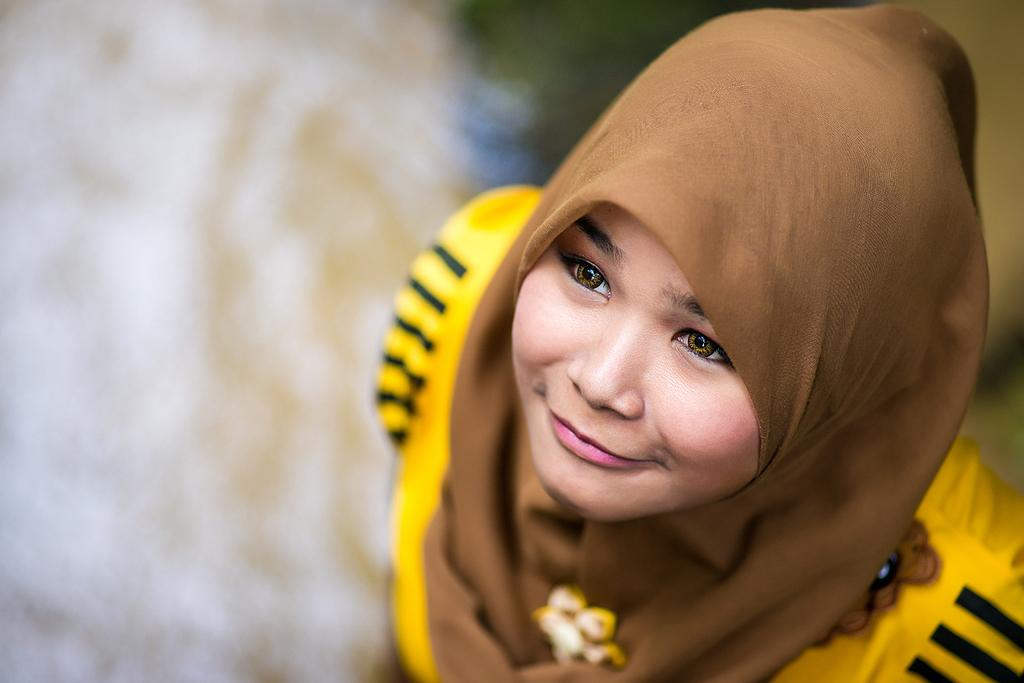What is the main subject of the image? There is a woman in the image. Can you describe the scarf the woman is wearing? The woman is wearing a scarf with yellow, black, and brown colors. What part of the image is not clear? The backside of the image is blurred. How many fish can be seen swimming in the scarf's pattern? There are no fish visible in the scarf's pattern; it features yellow, black, and brown colors. What type of power source is connected to the woman's scarf? There is no power source connected to the woman's scarf; it is a scarf made of fabric. 